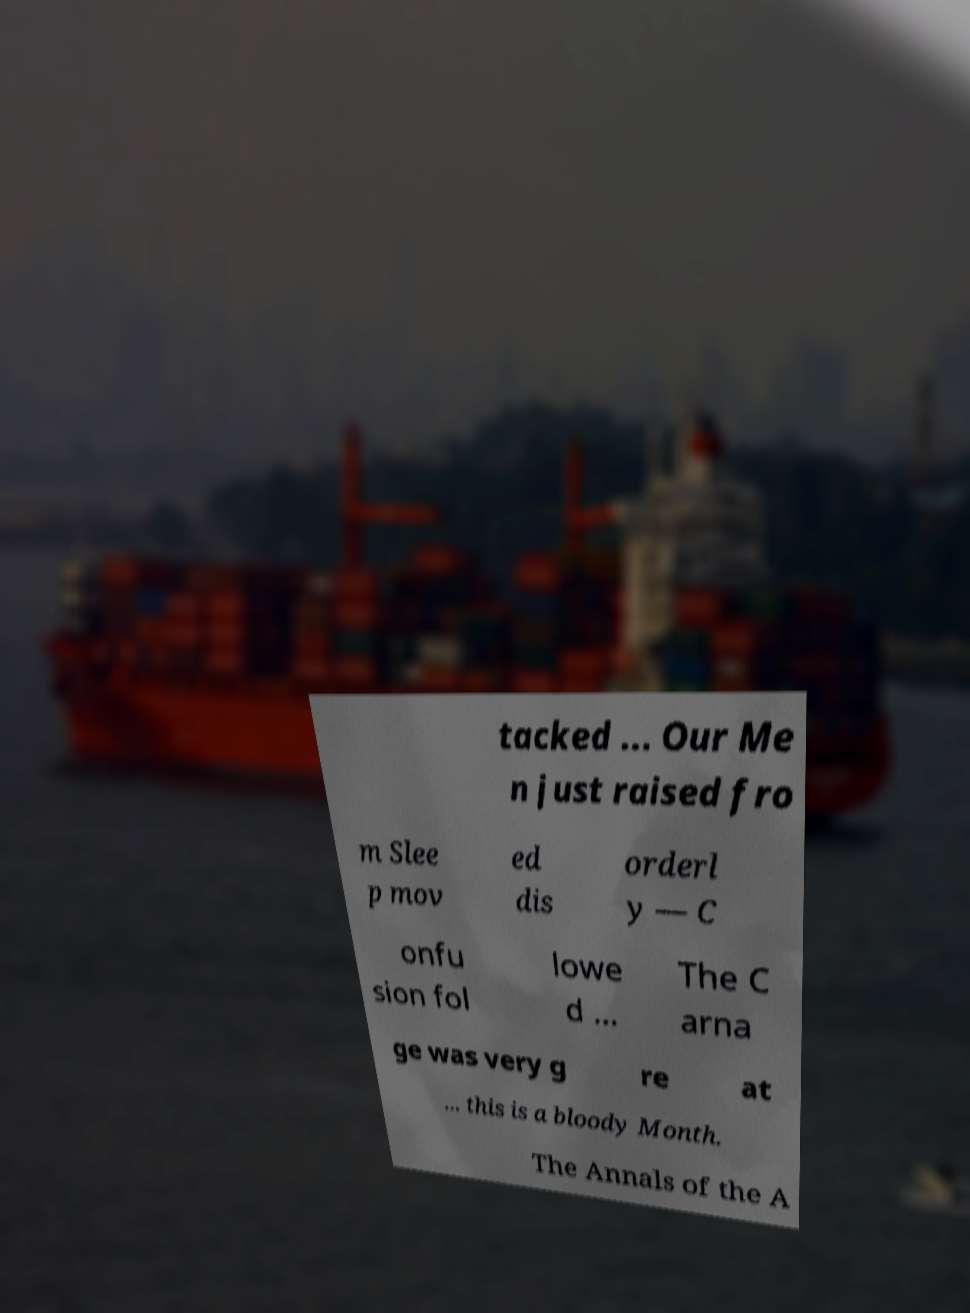For documentation purposes, I need the text within this image transcribed. Could you provide that? tacked ... Our Me n just raised fro m Slee p mov ed dis orderl y — C onfu sion fol lowe d ... The C arna ge was very g re at ... this is a bloody Month. The Annals of the A 